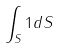Convert formula to latex. <formula><loc_0><loc_0><loc_500><loc_500>\int _ { S } 1 d S</formula> 